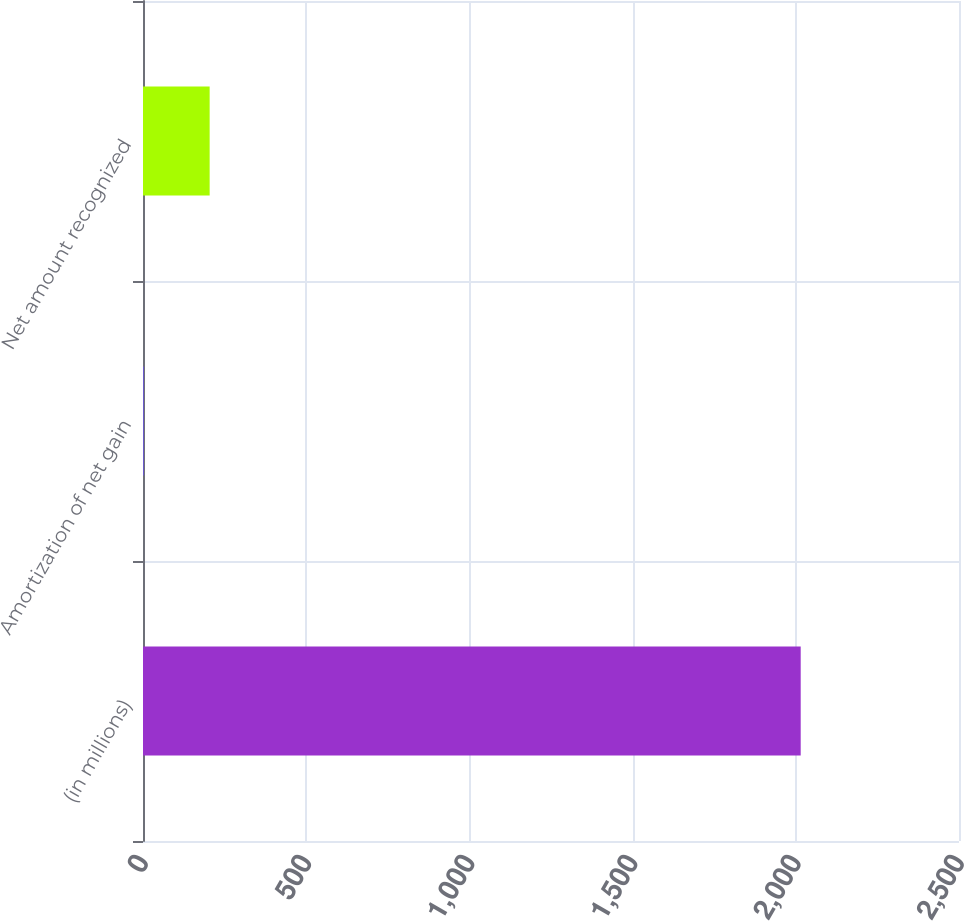Convert chart. <chart><loc_0><loc_0><loc_500><loc_500><bar_chart><fcel>(in millions)<fcel>Amortization of net gain<fcel>Net amount recognized<nl><fcel>2015<fcel>3<fcel>204.2<nl></chart> 